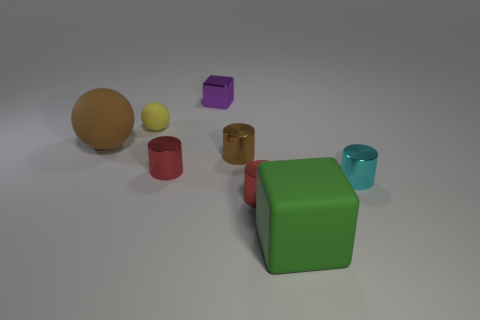Add 2 cubes. How many objects exist? 10 Subtract all spheres. How many objects are left? 6 Add 6 big blocks. How many big blocks are left? 7 Add 1 purple rubber cubes. How many purple rubber cubes exist? 1 Subtract 0 blue cubes. How many objects are left? 8 Subtract all brown cylinders. Subtract all brown metal cylinders. How many objects are left? 6 